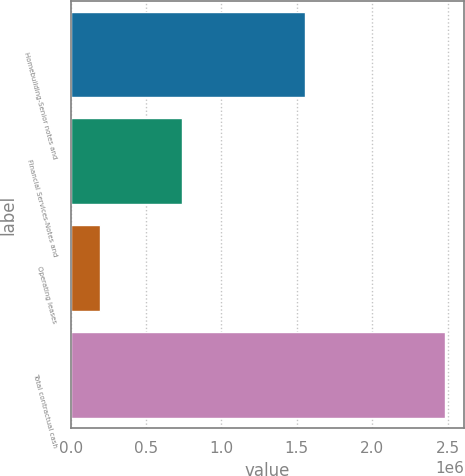Convert chart. <chart><loc_0><loc_0><loc_500><loc_500><bar_chart><fcel>Homebuilding-Senior notes and<fcel>Financial Services-Notes and<fcel>Operating leases<fcel>Total contractual cash<nl><fcel>1.55222e+06<fcel>740469<fcel>192710<fcel>2.4854e+06<nl></chart> 